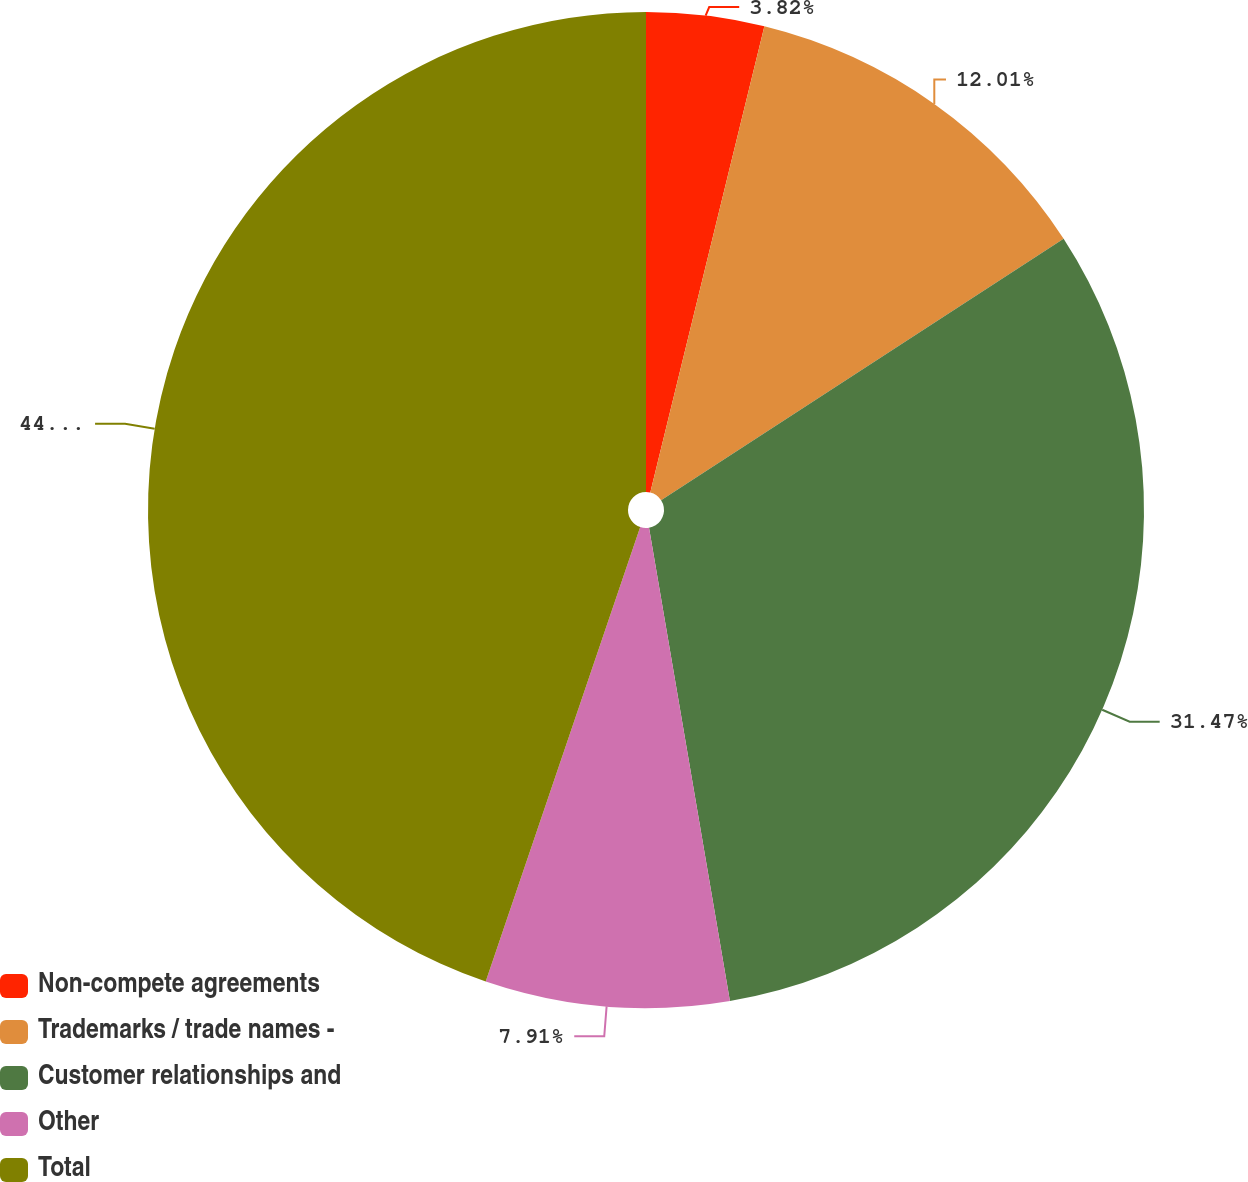<chart> <loc_0><loc_0><loc_500><loc_500><pie_chart><fcel>Non-compete agreements<fcel>Trademarks / trade names -<fcel>Customer relationships and<fcel>Other<fcel>Total<nl><fcel>3.82%<fcel>12.01%<fcel>31.47%<fcel>7.91%<fcel>44.78%<nl></chart> 